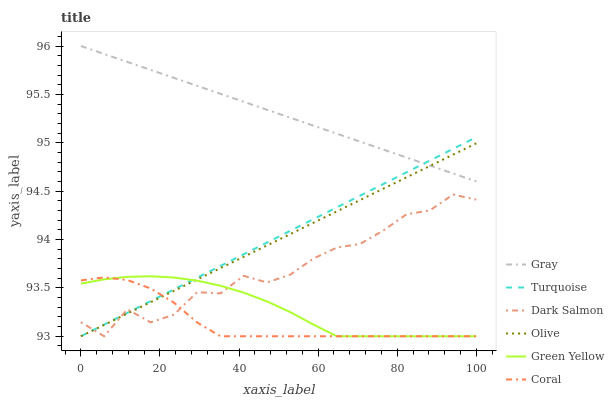Does Coral have the minimum area under the curve?
Answer yes or no. Yes. Does Gray have the maximum area under the curve?
Answer yes or no. Yes. Does Turquoise have the minimum area under the curve?
Answer yes or no. No. Does Turquoise have the maximum area under the curve?
Answer yes or no. No. Is Gray the smoothest?
Answer yes or no. Yes. Is Dark Salmon the roughest?
Answer yes or no. Yes. Is Turquoise the smoothest?
Answer yes or no. No. Is Turquoise the roughest?
Answer yes or no. No. Does Turquoise have the lowest value?
Answer yes or no. Yes. Does Gray have the highest value?
Answer yes or no. Yes. Does Turquoise have the highest value?
Answer yes or no. No. Is Green Yellow less than Gray?
Answer yes or no. Yes. Is Gray greater than Coral?
Answer yes or no. Yes. Does Olive intersect Turquoise?
Answer yes or no. Yes. Is Olive less than Turquoise?
Answer yes or no. No. Is Olive greater than Turquoise?
Answer yes or no. No. Does Green Yellow intersect Gray?
Answer yes or no. No. 